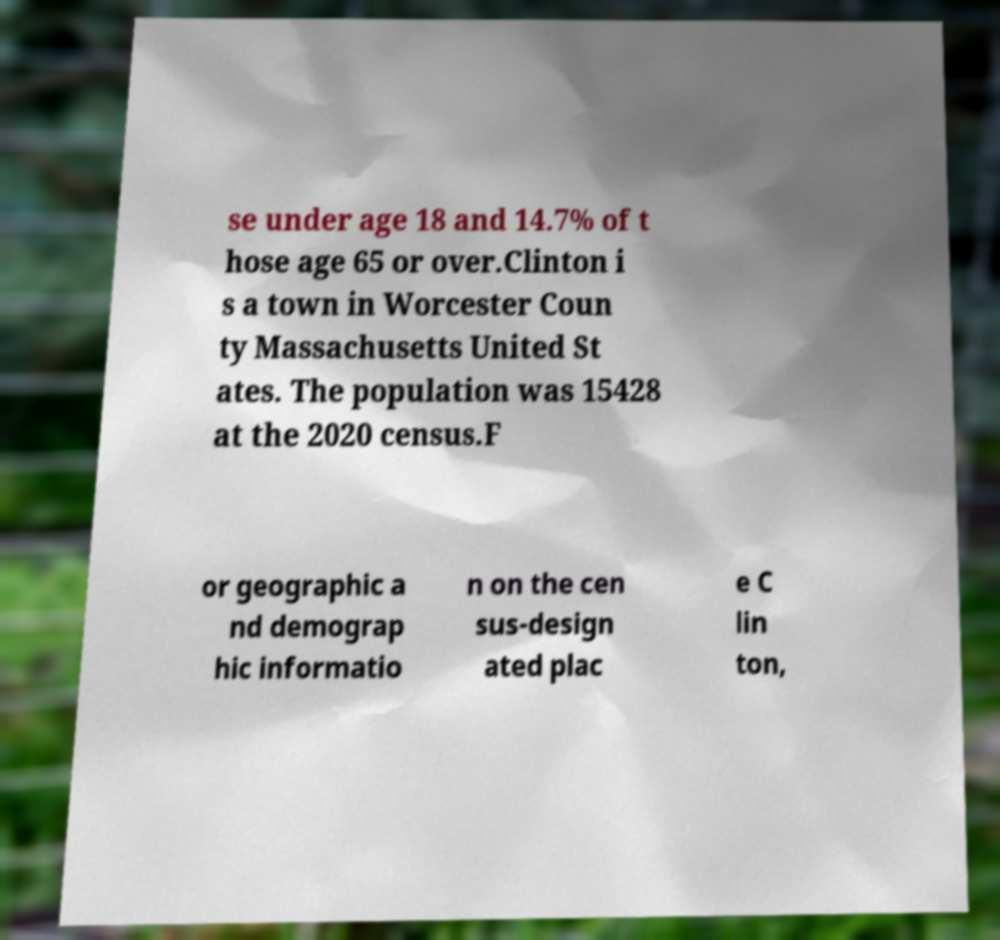Please read and relay the text visible in this image. What does it say? se under age 18 and 14.7% of t hose age 65 or over.Clinton i s a town in Worcester Coun ty Massachusetts United St ates. The population was 15428 at the 2020 census.F or geographic a nd demograp hic informatio n on the cen sus-design ated plac e C lin ton, 